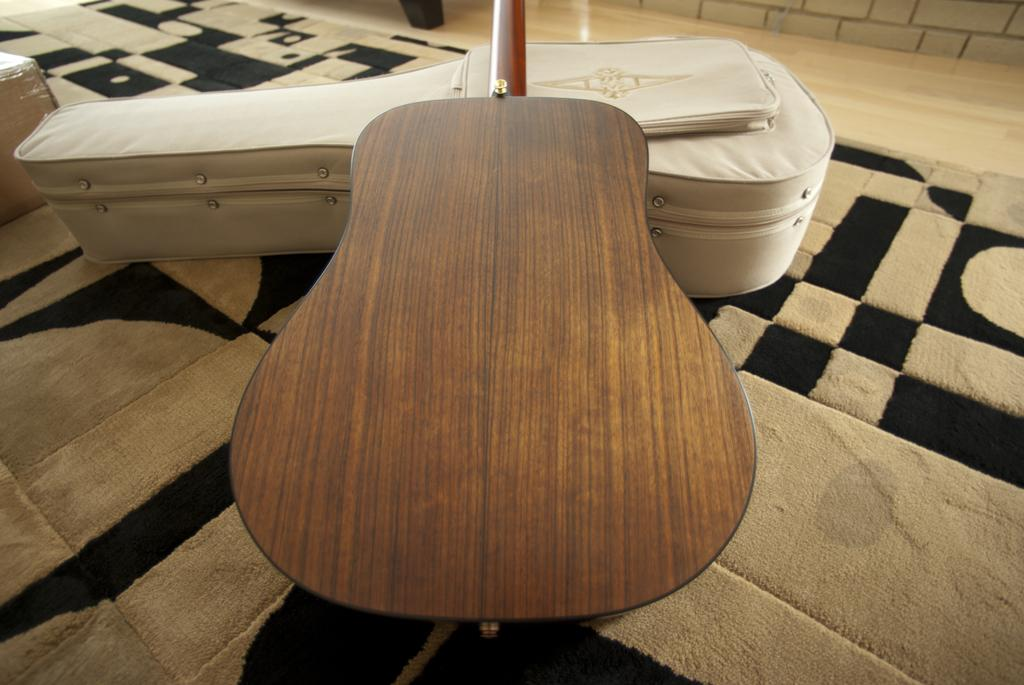What musical instrument is present in the image? There is a guitar in the image. Is there anything accompanying the guitar in the image? Yes, there is a guitar bag in the image. What type of flooring is visible in the image? There is a carpet in the image. What type of juice is being squeezed out of the heart in the image? There is no juice or heart present in the image; it only features a guitar and a guitar bag on a carpet. 